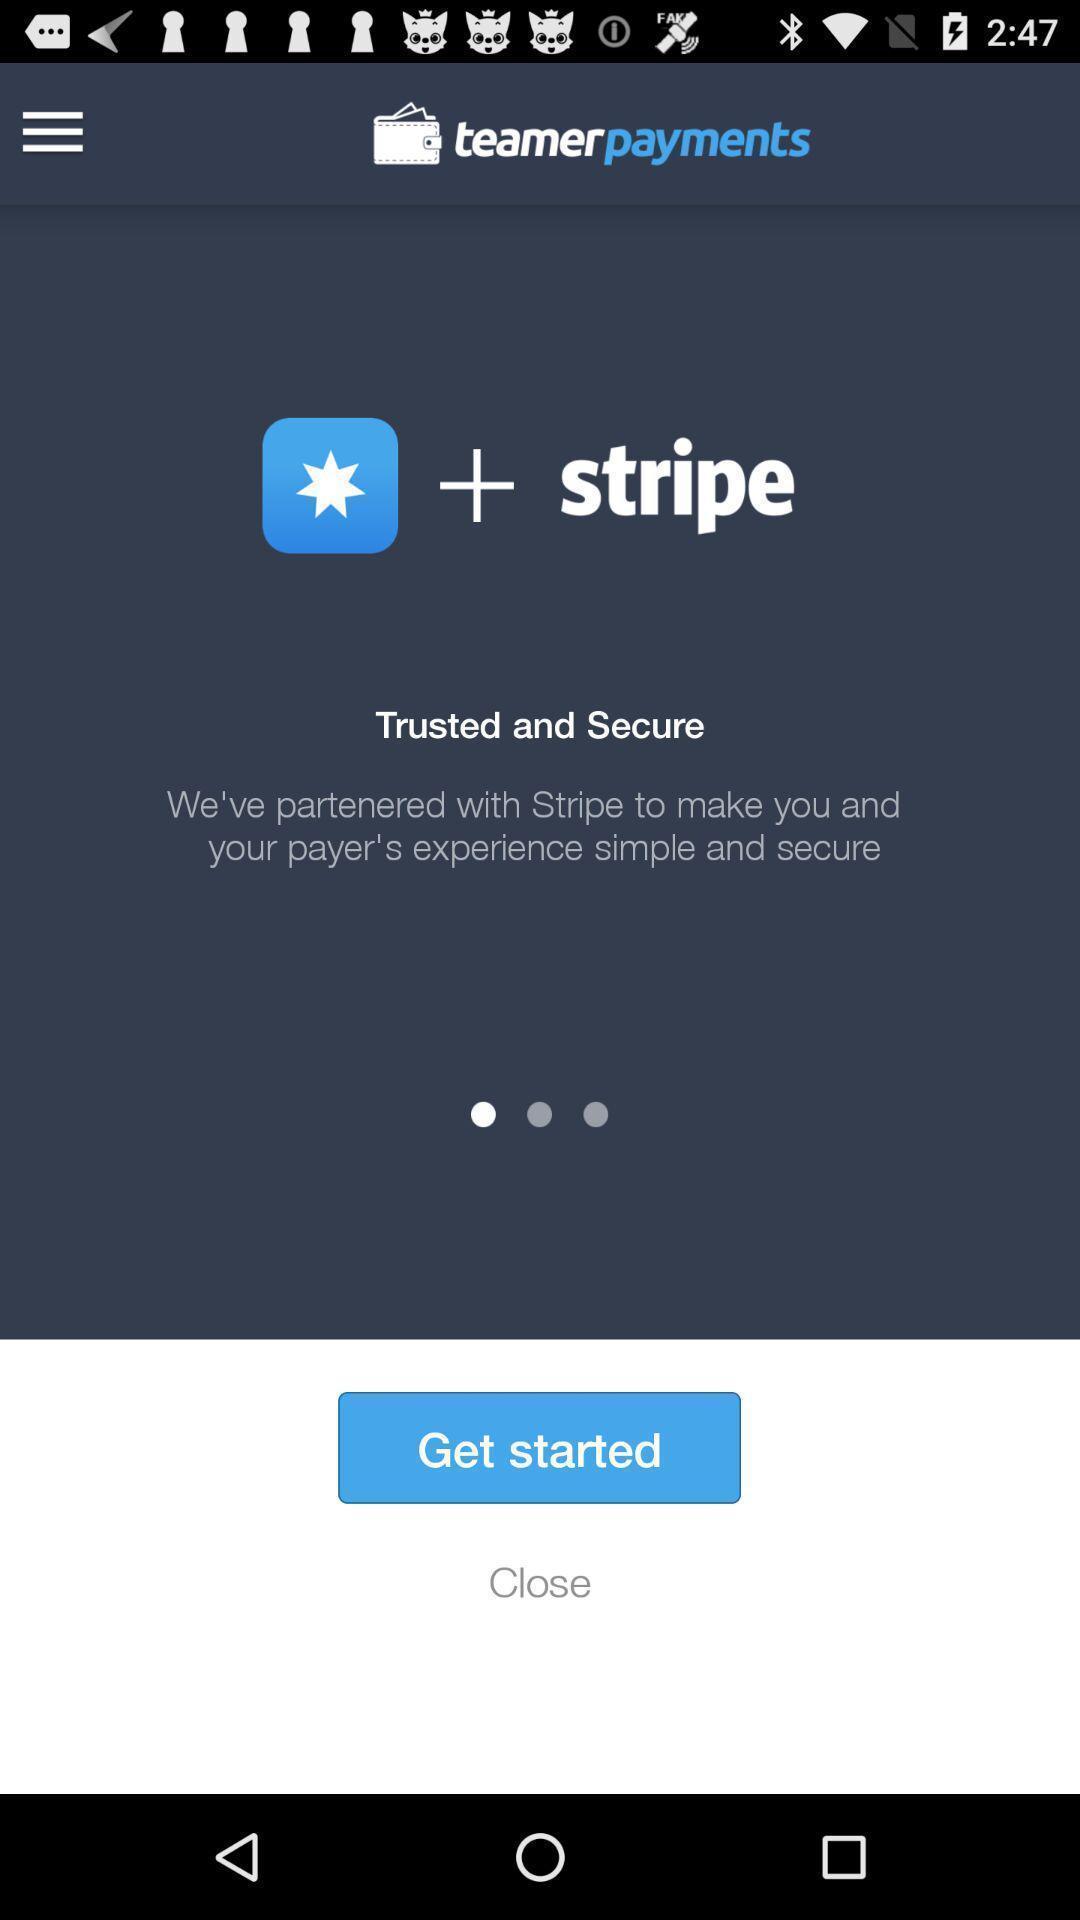Describe the key features of this screenshot. Welcome page of a finance app. 